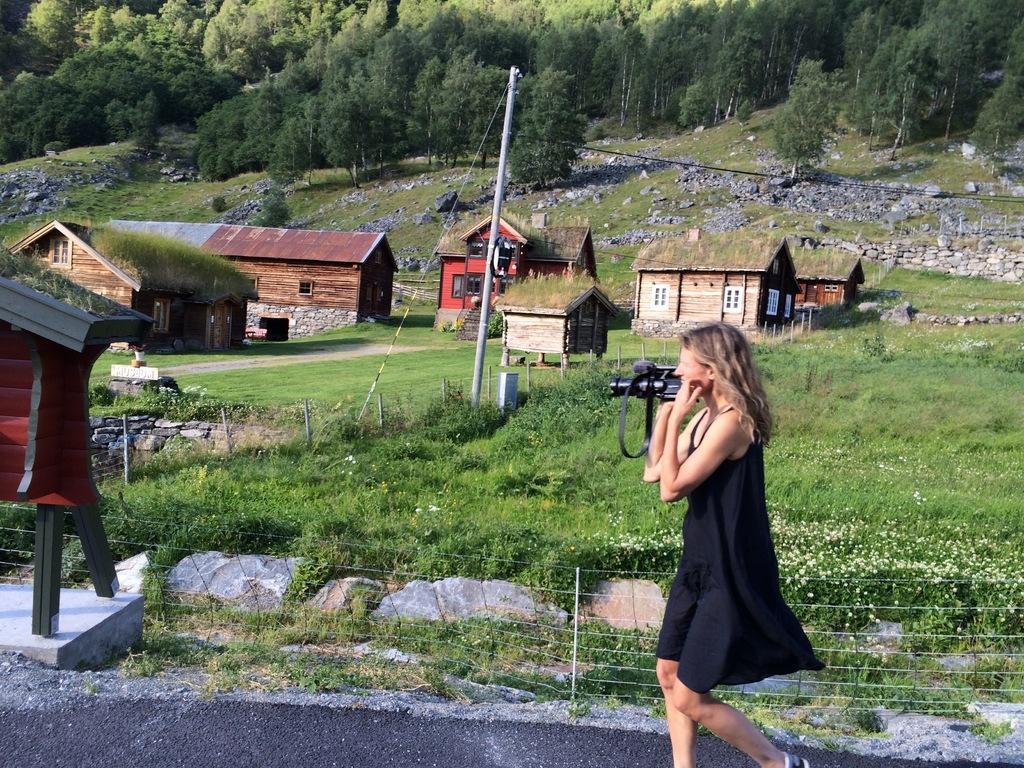How would you summarize this image in a sentence or two? On the right side, there is a woman in a black color dress, holding a camera with one hand and walking on the road. Beside this road, there is a fence. In the background, there are houses, trees, stones and grass on the ground. 